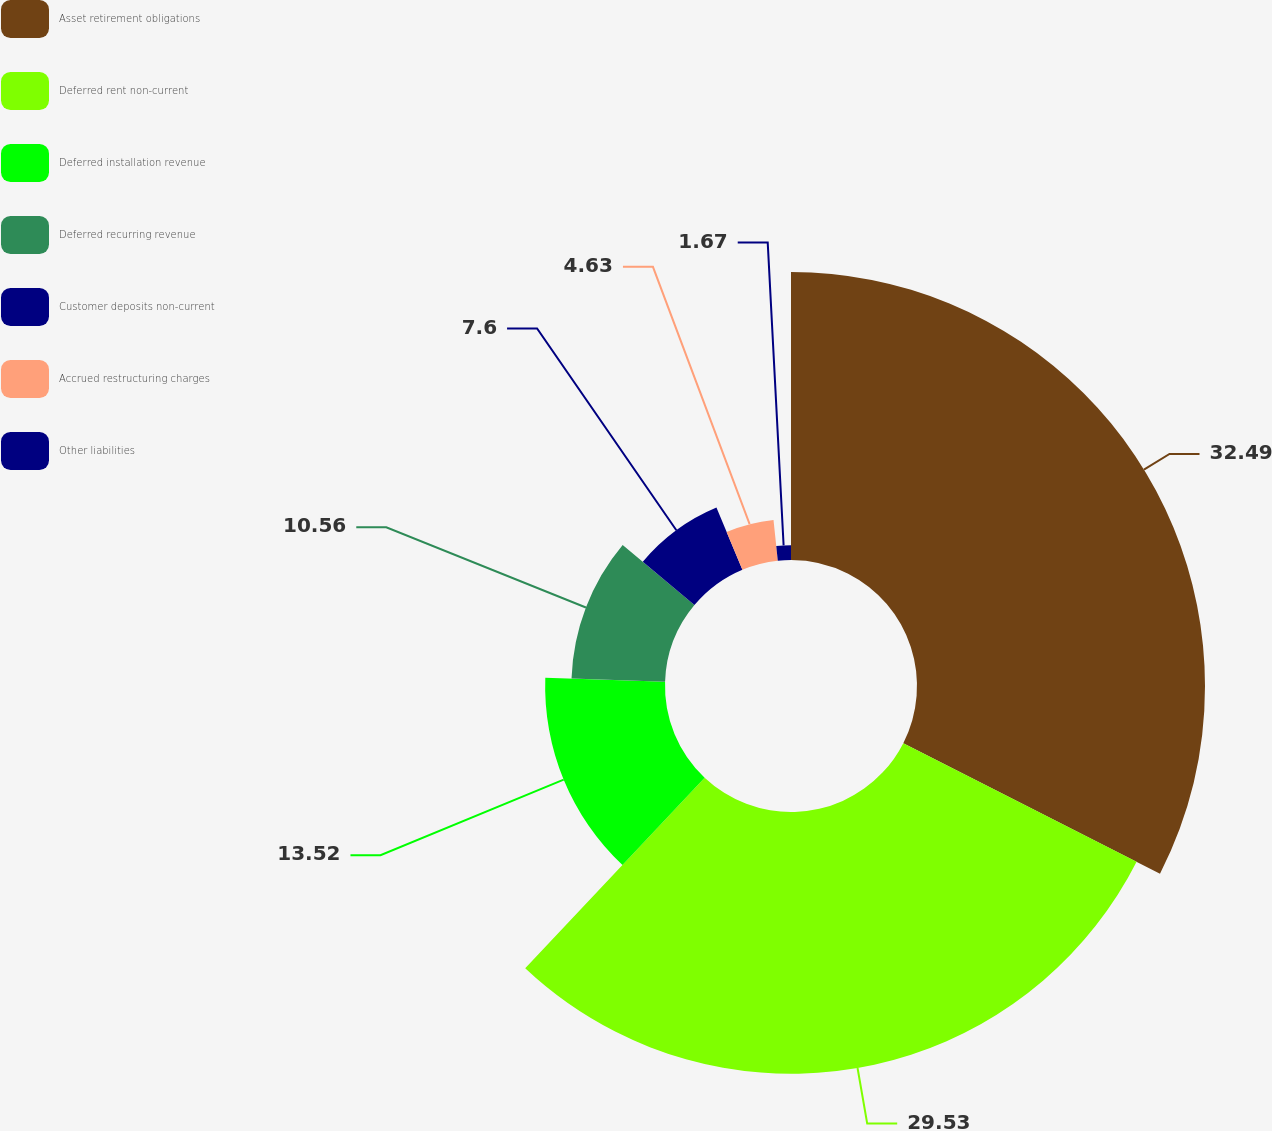Convert chart. <chart><loc_0><loc_0><loc_500><loc_500><pie_chart><fcel>Asset retirement obligations<fcel>Deferred rent non-current<fcel>Deferred installation revenue<fcel>Deferred recurring revenue<fcel>Customer deposits non-current<fcel>Accrued restructuring charges<fcel>Other liabilities<nl><fcel>32.49%<fcel>29.53%<fcel>13.52%<fcel>10.56%<fcel>7.6%<fcel>4.63%<fcel>1.67%<nl></chart> 